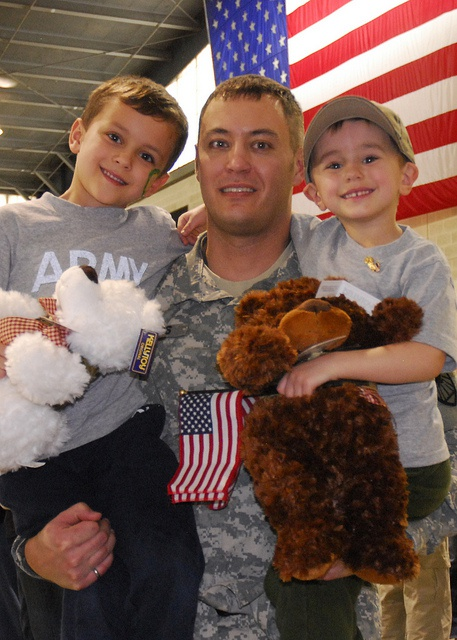Describe the objects in this image and their specific colors. I can see people in black and gray tones, people in black, gray, brown, and maroon tones, teddy bear in black, maroon, and brown tones, people in black, brown, darkgray, and gray tones, and teddy bear in black, lightgray, and darkgray tones in this image. 